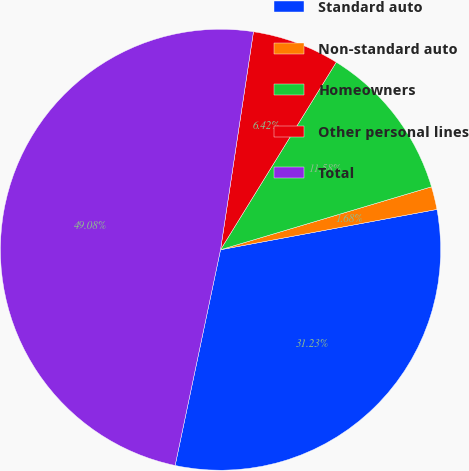<chart> <loc_0><loc_0><loc_500><loc_500><pie_chart><fcel>Standard auto<fcel>Non-standard auto<fcel>Homeowners<fcel>Other personal lines<fcel>Total<nl><fcel>31.23%<fcel>1.68%<fcel>11.58%<fcel>6.42%<fcel>49.08%<nl></chart> 